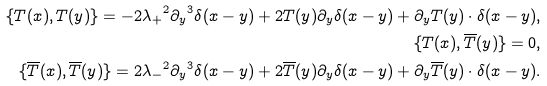<formula> <loc_0><loc_0><loc_500><loc_500>\{ T ( x ) , T ( y ) \} = - 2 { \lambda _ { + } } ^ { 2 } { \partial _ { y } } ^ { 3 } \delta ( x - y ) + 2 T ( y ) \partial _ { y } \delta ( x - y ) + \partial _ { y } T ( y ) \cdot \delta ( x - y ) , \\ \{ T ( x ) , { \overline { T } } ( y ) \} = 0 , \\ \{ { \overline { T } } ( x ) , { \overline { T } } ( y ) \} = 2 { \lambda _ { - } } ^ { 2 } { \partial _ { y } } ^ { 3 } \delta ( x - y ) + 2 { \overline { T } } ( y ) \partial _ { y } \delta ( x - y ) + \partial _ { y } { \overline { T } } ( y ) \cdot \delta ( x - y ) .</formula> 